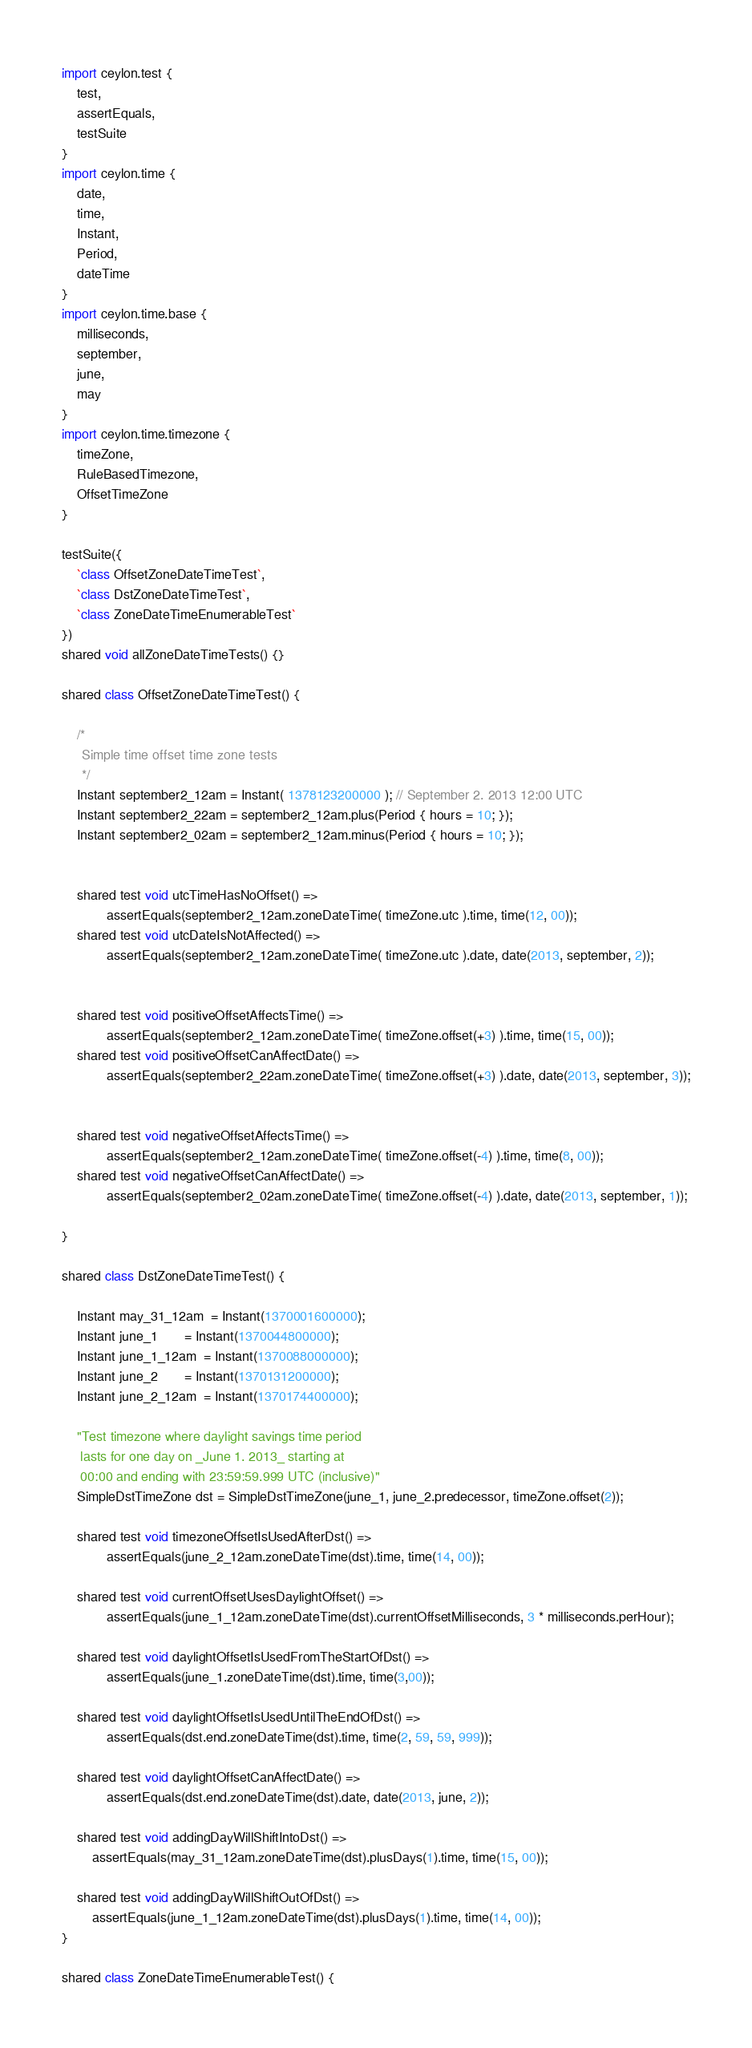<code> <loc_0><loc_0><loc_500><loc_500><_Ceylon_>import ceylon.test {
    test,
    assertEquals,
    testSuite
}
import ceylon.time {
    date,
    time,
    Instant,
    Period,
    dateTime
}
import ceylon.time.base {
    milliseconds,
    september,
    june,
    may
}
import ceylon.time.timezone {
    timeZone,
    RuleBasedTimezone,
    OffsetTimeZone
}

testSuite({
    `class OffsetZoneDateTimeTest`,
    `class DstZoneDateTimeTest`,    
    `class ZoneDateTimeEnumerableTest`    
})
shared void allZoneDateTimeTests() {}

shared class OffsetZoneDateTimeTest() {

    /*
     Simple time offset time zone tests
     */
    Instant september2_12am = Instant( 1378123200000 ); // September 2. 2013 12:00 UTC
    Instant september2_22am = september2_12am.plus(Period { hours = 10; });
    Instant september2_02am = september2_12am.minus(Period { hours = 10; });
    
    
    shared test void utcTimeHasNoOffset() =>
            assertEquals(september2_12am.zoneDateTime( timeZone.utc ).time, time(12, 00));
    shared test void utcDateIsNotAffected() =>
            assertEquals(september2_12am.zoneDateTime( timeZone.utc ).date, date(2013, september, 2));

    
    shared test void positiveOffsetAffectsTime() =>
            assertEquals(september2_12am.zoneDateTime( timeZone.offset(+3) ).time, time(15, 00));
    shared test void positiveOffsetCanAffectDate() =>
            assertEquals(september2_22am.zoneDateTime( timeZone.offset(+3) ).date, date(2013, september, 3));

    
    shared test void negativeOffsetAffectsTime() =>
            assertEquals(september2_12am.zoneDateTime( timeZone.offset(-4) ).time, time(8, 00));
    shared test void negativeOffsetCanAffectDate() =>
            assertEquals(september2_02am.zoneDateTime( timeZone.offset(-4) ).date, date(2013, september, 1));
    
}

shared class DstZoneDateTimeTest() {

    Instant may_31_12am  = Instant(1370001600000);
    Instant june_1       = Instant(1370044800000);
    Instant june_1_12am  = Instant(1370088000000);
    Instant june_2       = Instant(1370131200000);
    Instant june_2_12am  = Instant(1370174400000);

    "Test timezone where daylight savings time period 
     lasts for one day on _June 1. 2013_ starting at 
     00:00 and ending with 23:59:59.999 UTC (inclusive)"
    SimpleDstTimeZone dst = SimpleDstTimeZone(june_1, june_2.predecessor, timeZone.offset(2));

    shared test void timezoneOffsetIsUsedAfterDst() =>
            assertEquals(june_2_12am.zoneDateTime(dst).time, time(14, 00));

    shared test void currentOffsetUsesDaylightOffset() =>
            assertEquals(june_1_12am.zoneDateTime(dst).currentOffsetMilliseconds, 3 * milliseconds.perHour);

    shared test void daylightOffsetIsUsedFromTheStartOfDst() =>
            assertEquals(june_1.zoneDateTime(dst).time, time(3,00));

    shared test void daylightOffsetIsUsedUntilTheEndOfDst() =>
            assertEquals(dst.end.zoneDateTime(dst).time, time(2, 59, 59, 999));

    shared test void daylightOffsetCanAffectDate() =>
            assertEquals(dst.end.zoneDateTime(dst).date, date(2013, june, 2));

    shared test void addingDayWillShiftIntoDst() =>
        assertEquals(may_31_12am.zoneDateTime(dst).plusDays(1).time, time(15, 00));

    shared test void addingDayWillShiftOutOfDst() =>
        assertEquals(june_1_12am.zoneDateTime(dst).plusDays(1).time, time(14, 00));
}

shared class ZoneDateTimeEnumerableTest() {</code> 